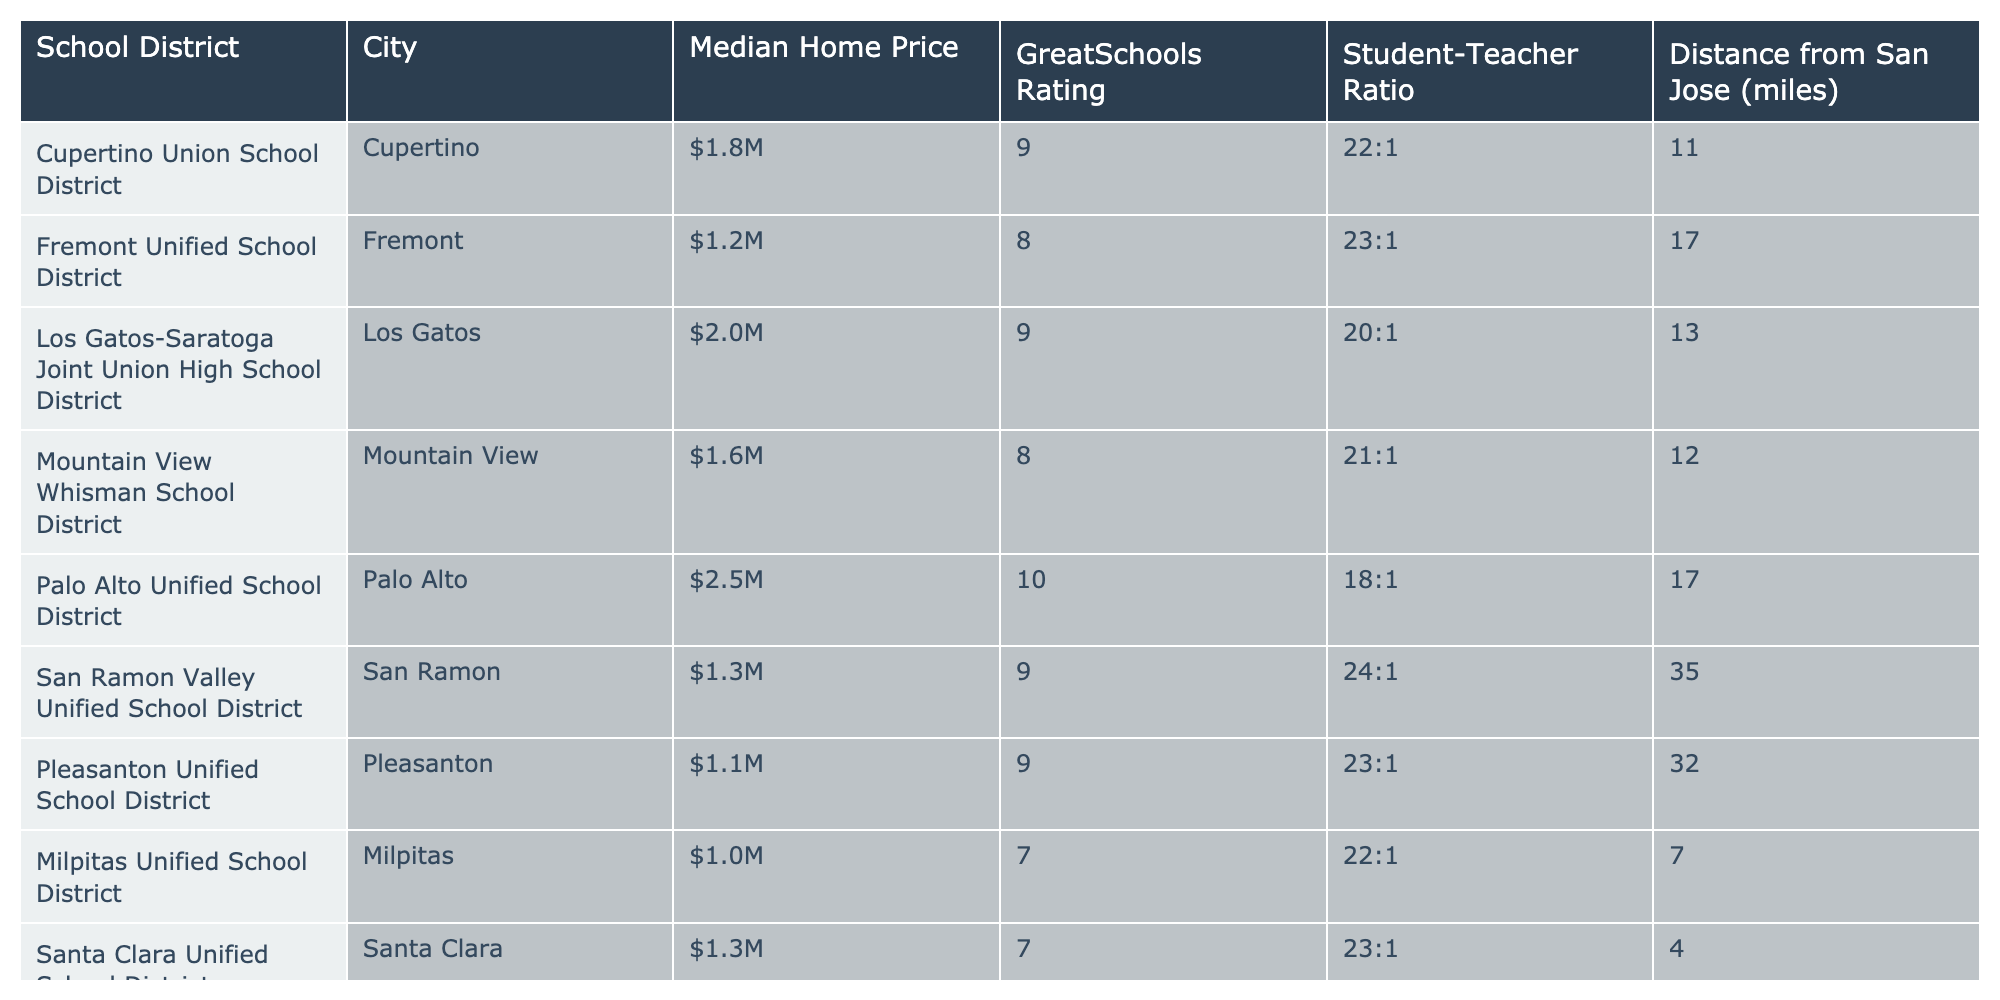What is the median home price in Cupertino? According to the table, the median home price listed under Cupertino Union School District is $1.8M.
Answer: $1.8M Which school district has the highest GreatSchools rating? The highest rating is 10, corresponding to the Palo Alto Unified School District.
Answer: Palo Alto Unified School District What is the average student-teacher ratio of the districts listed? To calculate the average, we sum the student-teacher ratios: (22 + 23 + 20 + 21 + 18 + 24 + 23 + 22 + 23 + 22) =  227. There are 10 districts, so the average is 227/10 = 22.7.
Answer: 22.7 Is the median home price in Pleasanton lower than in Fremont? The median home price in Pleasanton is $1.1M, while in Fremont it is $1.2M. Since $1.1M is less than $1.2M, this statement is true.
Answer: Yes Which city is closest to San Jose? The table lists Milpitas Unified School District with a distance of 7 miles from San Jose, which is the shortest compared to all other districts.
Answer: Milpitas How many districts have a GreatSchools rating of 9 or higher? The districts with a rating of 9 or higher are Cupertino, Los Gatos, Palo Alto, San Ramon, and Pleasanton. Counting these, there are 5 districts that meet the criteria.
Answer: 5 What is the difference in median home price between Palo Alto and Milpitas? The median home price for Palo Alto is $2.5M and for Milpitas, it is $1.0M. The difference is $2.5M - $1.0M = $1.5M.
Answer: $1.5M Is the student-teacher ratio in Sunnyvale higher than that in Cupertino? Sunnyvale has a student-teacher ratio of 22:1 and Cupertino has 22:1 as well. Since both ratios are the same, this statement is false.
Answer: No What is the total distance from San Jose for the district with the lowest home price? The lowest median home price is for Milpitas at $1.0M, with a distance of 7 miles from San Jose. Therefore, the total distance is simply 7 miles.
Answer: 7 miles 